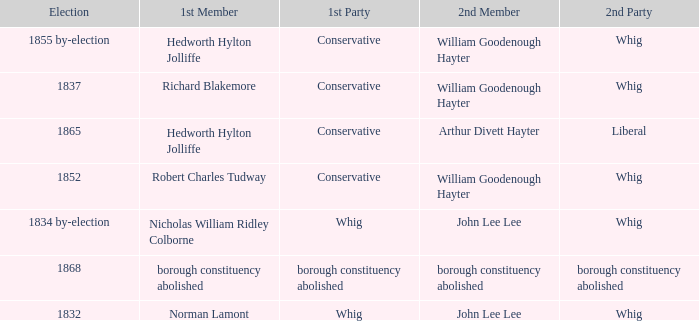Who's the conservative 1st member of the election of 1852? Robert Charles Tudway. 